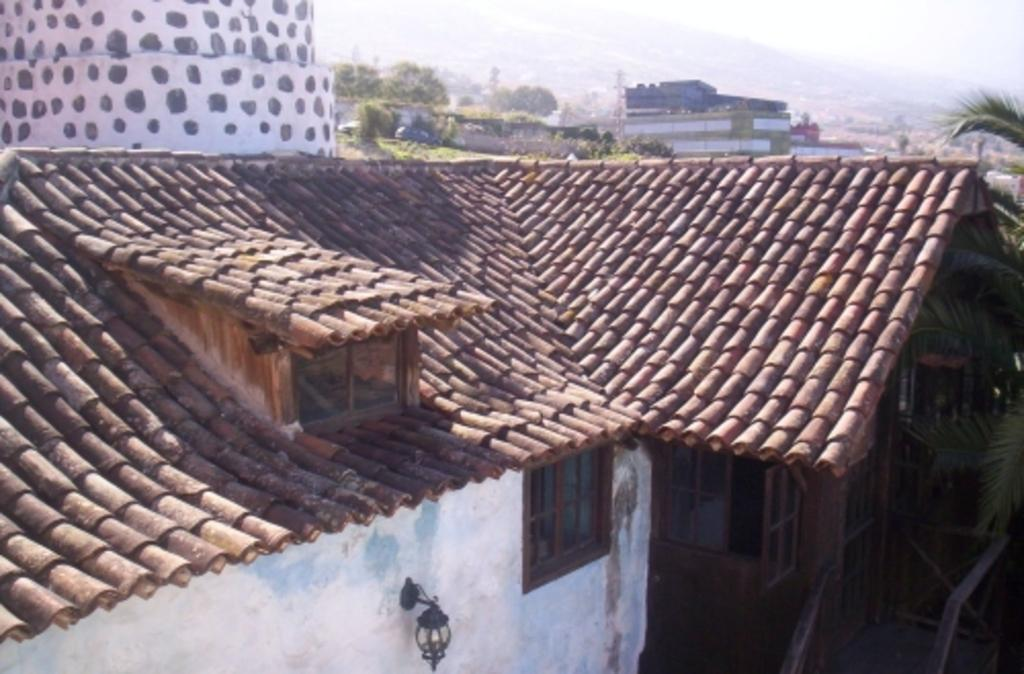What type of structure is visible in the image? There is a building with windows in the image. Can you describe any specific features of the building? There is a light on the wall of the building. What can be seen in the background of the image? There are trees and other buildings in the background of the image. What type of produce is being sold at the train station in the image? There is no train station or produce present in the image; it features a building with windows, a light on the wall, trees, and other buildings in the background. 